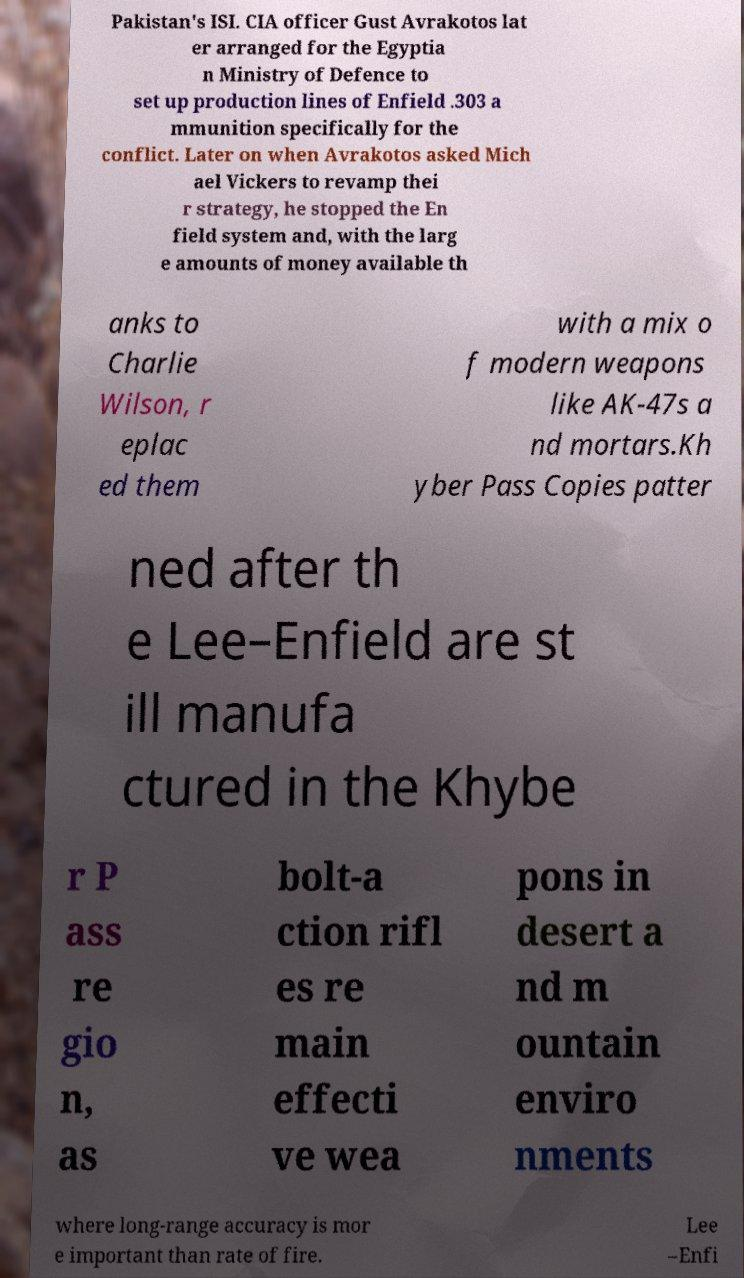Could you extract and type out the text from this image? Pakistan's ISI. CIA officer Gust Avrakotos lat er arranged for the Egyptia n Ministry of Defence to set up production lines of Enfield .303 a mmunition specifically for the conflict. Later on when Avrakotos asked Mich ael Vickers to revamp thei r strategy, he stopped the En field system and, with the larg e amounts of money available th anks to Charlie Wilson, r eplac ed them with a mix o f modern weapons like AK-47s a nd mortars.Kh yber Pass Copies patter ned after th e Lee–Enfield are st ill manufa ctured in the Khybe r P ass re gio n, as bolt-a ction rifl es re main effecti ve wea pons in desert a nd m ountain enviro nments where long-range accuracy is mor e important than rate of fire. Lee –Enfi 